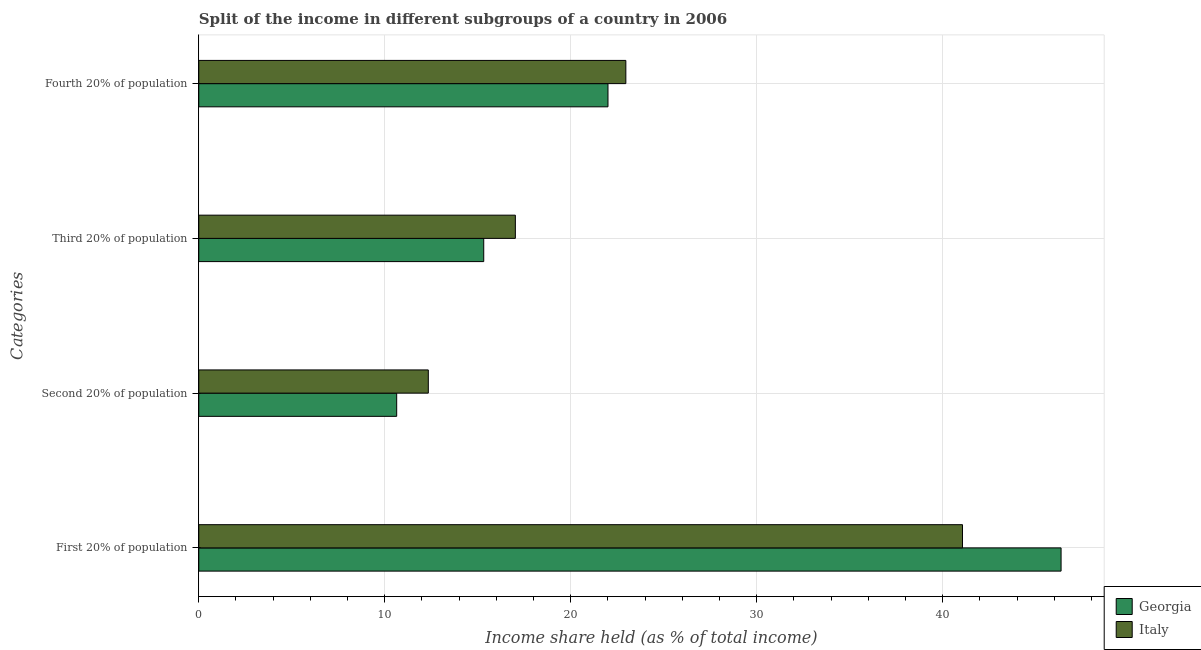How many different coloured bars are there?
Give a very brief answer. 2. How many groups of bars are there?
Make the answer very short. 4. Are the number of bars on each tick of the Y-axis equal?
Make the answer very short. Yes. How many bars are there on the 3rd tick from the bottom?
Provide a succinct answer. 2. What is the label of the 3rd group of bars from the top?
Offer a terse response. Second 20% of population. What is the share of the income held by second 20% of the population in Italy?
Make the answer very short. 12.34. Across all countries, what is the maximum share of the income held by second 20% of the population?
Provide a succinct answer. 12.34. Across all countries, what is the minimum share of the income held by third 20% of the population?
Your answer should be very brief. 15.32. In which country was the share of the income held by third 20% of the population maximum?
Your answer should be very brief. Italy. In which country was the share of the income held by third 20% of the population minimum?
Your answer should be very brief. Georgia. What is the total share of the income held by first 20% of the population in the graph?
Provide a succinct answer. 87.42. What is the difference between the share of the income held by fourth 20% of the population in Georgia and that in Italy?
Your answer should be very brief. -0.96. What is the difference between the share of the income held by third 20% of the population in Italy and the share of the income held by first 20% of the population in Georgia?
Ensure brevity in your answer.  -29.34. What is the average share of the income held by first 20% of the population per country?
Give a very brief answer. 43.71. What is the difference between the share of the income held by fourth 20% of the population and share of the income held by second 20% of the population in Italy?
Ensure brevity in your answer.  10.62. In how many countries, is the share of the income held by third 20% of the population greater than 40 %?
Give a very brief answer. 0. What is the ratio of the share of the income held by fourth 20% of the population in Italy to that in Georgia?
Provide a succinct answer. 1.04. Is the share of the income held by fourth 20% of the population in Italy less than that in Georgia?
Your answer should be very brief. No. What is the difference between the highest and the second highest share of the income held by second 20% of the population?
Keep it short and to the point. 1.7. What is the difference between the highest and the lowest share of the income held by first 20% of the population?
Ensure brevity in your answer.  5.3. In how many countries, is the share of the income held by second 20% of the population greater than the average share of the income held by second 20% of the population taken over all countries?
Make the answer very short. 1. What does the 2nd bar from the top in Second 20% of population represents?
Give a very brief answer. Georgia. How many bars are there?
Provide a succinct answer. 8. Are all the bars in the graph horizontal?
Provide a succinct answer. Yes. What is the difference between two consecutive major ticks on the X-axis?
Keep it short and to the point. 10. Does the graph contain grids?
Your answer should be compact. Yes. Where does the legend appear in the graph?
Offer a very short reply. Bottom right. How many legend labels are there?
Your response must be concise. 2. How are the legend labels stacked?
Ensure brevity in your answer.  Vertical. What is the title of the graph?
Make the answer very short. Split of the income in different subgroups of a country in 2006. What is the label or title of the X-axis?
Keep it short and to the point. Income share held (as % of total income). What is the label or title of the Y-axis?
Your answer should be compact. Categories. What is the Income share held (as % of total income) in Georgia in First 20% of population?
Your answer should be very brief. 46.36. What is the Income share held (as % of total income) of Italy in First 20% of population?
Make the answer very short. 41.06. What is the Income share held (as % of total income) in Georgia in Second 20% of population?
Your answer should be very brief. 10.64. What is the Income share held (as % of total income) of Italy in Second 20% of population?
Ensure brevity in your answer.  12.34. What is the Income share held (as % of total income) in Georgia in Third 20% of population?
Offer a very short reply. 15.32. What is the Income share held (as % of total income) of Italy in Third 20% of population?
Keep it short and to the point. 17.02. What is the Income share held (as % of total income) of Georgia in Fourth 20% of population?
Your answer should be compact. 22. What is the Income share held (as % of total income) of Italy in Fourth 20% of population?
Offer a very short reply. 22.96. Across all Categories, what is the maximum Income share held (as % of total income) in Georgia?
Give a very brief answer. 46.36. Across all Categories, what is the maximum Income share held (as % of total income) of Italy?
Make the answer very short. 41.06. Across all Categories, what is the minimum Income share held (as % of total income) of Georgia?
Offer a very short reply. 10.64. Across all Categories, what is the minimum Income share held (as % of total income) in Italy?
Offer a very short reply. 12.34. What is the total Income share held (as % of total income) of Georgia in the graph?
Your response must be concise. 94.32. What is the total Income share held (as % of total income) in Italy in the graph?
Give a very brief answer. 93.38. What is the difference between the Income share held (as % of total income) of Georgia in First 20% of population and that in Second 20% of population?
Your answer should be compact. 35.72. What is the difference between the Income share held (as % of total income) in Italy in First 20% of population and that in Second 20% of population?
Offer a very short reply. 28.72. What is the difference between the Income share held (as % of total income) of Georgia in First 20% of population and that in Third 20% of population?
Provide a succinct answer. 31.04. What is the difference between the Income share held (as % of total income) of Italy in First 20% of population and that in Third 20% of population?
Provide a succinct answer. 24.04. What is the difference between the Income share held (as % of total income) in Georgia in First 20% of population and that in Fourth 20% of population?
Offer a terse response. 24.36. What is the difference between the Income share held (as % of total income) in Italy in First 20% of population and that in Fourth 20% of population?
Ensure brevity in your answer.  18.1. What is the difference between the Income share held (as % of total income) of Georgia in Second 20% of population and that in Third 20% of population?
Offer a terse response. -4.68. What is the difference between the Income share held (as % of total income) of Italy in Second 20% of population and that in Third 20% of population?
Make the answer very short. -4.68. What is the difference between the Income share held (as % of total income) of Georgia in Second 20% of population and that in Fourth 20% of population?
Ensure brevity in your answer.  -11.36. What is the difference between the Income share held (as % of total income) of Italy in Second 20% of population and that in Fourth 20% of population?
Your response must be concise. -10.62. What is the difference between the Income share held (as % of total income) of Georgia in Third 20% of population and that in Fourth 20% of population?
Your answer should be compact. -6.68. What is the difference between the Income share held (as % of total income) in Italy in Third 20% of population and that in Fourth 20% of population?
Make the answer very short. -5.94. What is the difference between the Income share held (as % of total income) of Georgia in First 20% of population and the Income share held (as % of total income) of Italy in Second 20% of population?
Provide a short and direct response. 34.02. What is the difference between the Income share held (as % of total income) in Georgia in First 20% of population and the Income share held (as % of total income) in Italy in Third 20% of population?
Offer a terse response. 29.34. What is the difference between the Income share held (as % of total income) in Georgia in First 20% of population and the Income share held (as % of total income) in Italy in Fourth 20% of population?
Your answer should be compact. 23.4. What is the difference between the Income share held (as % of total income) in Georgia in Second 20% of population and the Income share held (as % of total income) in Italy in Third 20% of population?
Your answer should be compact. -6.38. What is the difference between the Income share held (as % of total income) in Georgia in Second 20% of population and the Income share held (as % of total income) in Italy in Fourth 20% of population?
Offer a very short reply. -12.32. What is the difference between the Income share held (as % of total income) in Georgia in Third 20% of population and the Income share held (as % of total income) in Italy in Fourth 20% of population?
Ensure brevity in your answer.  -7.64. What is the average Income share held (as % of total income) in Georgia per Categories?
Your response must be concise. 23.58. What is the average Income share held (as % of total income) in Italy per Categories?
Ensure brevity in your answer.  23.34. What is the difference between the Income share held (as % of total income) of Georgia and Income share held (as % of total income) of Italy in Second 20% of population?
Your response must be concise. -1.7. What is the difference between the Income share held (as % of total income) of Georgia and Income share held (as % of total income) of Italy in Fourth 20% of population?
Keep it short and to the point. -0.96. What is the ratio of the Income share held (as % of total income) of Georgia in First 20% of population to that in Second 20% of population?
Offer a terse response. 4.36. What is the ratio of the Income share held (as % of total income) in Italy in First 20% of population to that in Second 20% of population?
Give a very brief answer. 3.33. What is the ratio of the Income share held (as % of total income) of Georgia in First 20% of population to that in Third 20% of population?
Offer a very short reply. 3.03. What is the ratio of the Income share held (as % of total income) in Italy in First 20% of population to that in Third 20% of population?
Provide a short and direct response. 2.41. What is the ratio of the Income share held (as % of total income) in Georgia in First 20% of population to that in Fourth 20% of population?
Give a very brief answer. 2.11. What is the ratio of the Income share held (as % of total income) of Italy in First 20% of population to that in Fourth 20% of population?
Your answer should be compact. 1.79. What is the ratio of the Income share held (as % of total income) in Georgia in Second 20% of population to that in Third 20% of population?
Your answer should be compact. 0.69. What is the ratio of the Income share held (as % of total income) of Italy in Second 20% of population to that in Third 20% of population?
Make the answer very short. 0.72. What is the ratio of the Income share held (as % of total income) in Georgia in Second 20% of population to that in Fourth 20% of population?
Ensure brevity in your answer.  0.48. What is the ratio of the Income share held (as % of total income) of Italy in Second 20% of population to that in Fourth 20% of population?
Keep it short and to the point. 0.54. What is the ratio of the Income share held (as % of total income) in Georgia in Third 20% of population to that in Fourth 20% of population?
Your answer should be very brief. 0.7. What is the ratio of the Income share held (as % of total income) in Italy in Third 20% of population to that in Fourth 20% of population?
Offer a terse response. 0.74. What is the difference between the highest and the second highest Income share held (as % of total income) in Georgia?
Provide a succinct answer. 24.36. What is the difference between the highest and the second highest Income share held (as % of total income) of Italy?
Your response must be concise. 18.1. What is the difference between the highest and the lowest Income share held (as % of total income) of Georgia?
Keep it short and to the point. 35.72. What is the difference between the highest and the lowest Income share held (as % of total income) in Italy?
Your response must be concise. 28.72. 